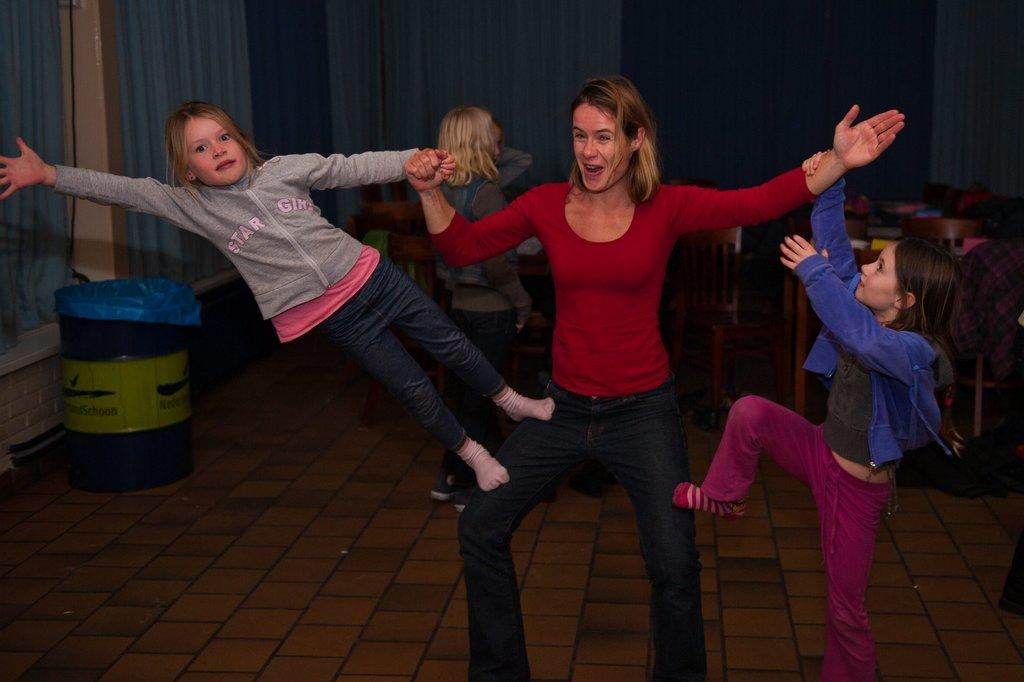Who is present in the image? There is a woman and kids in the image. What type of furniture is in the image? There are chairs in the image. What type of window treatment is present in the image? There are curtains in the image. Can you describe any other objects in the image? There are other unspecified objects in the image. Can you see a lake in the background of the image? There is no lake present in the image. How does the woman wave to the kids in the image? The image does not show the woman waving to the kids, so it cannot be determined from the image. 